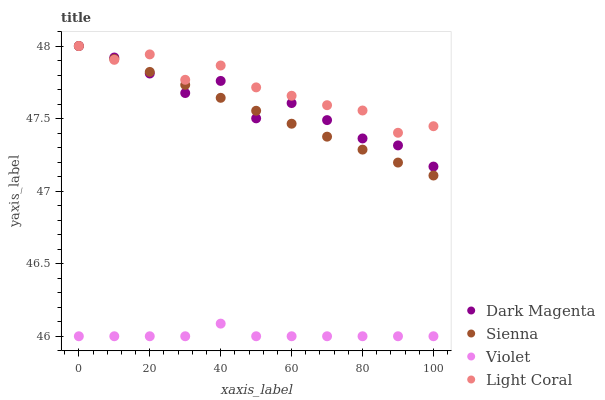Does Violet have the minimum area under the curve?
Answer yes or no. Yes. Does Light Coral have the maximum area under the curve?
Answer yes or no. Yes. Does Dark Magenta have the minimum area under the curve?
Answer yes or no. No. Does Dark Magenta have the maximum area under the curve?
Answer yes or no. No. Is Sienna the smoothest?
Answer yes or no. Yes. Is Dark Magenta the roughest?
Answer yes or no. Yes. Is Light Coral the smoothest?
Answer yes or no. No. Is Light Coral the roughest?
Answer yes or no. No. Does Violet have the lowest value?
Answer yes or no. Yes. Does Dark Magenta have the lowest value?
Answer yes or no. No. Does Dark Magenta have the highest value?
Answer yes or no. Yes. Does Violet have the highest value?
Answer yes or no. No. Is Violet less than Sienna?
Answer yes or no. Yes. Is Light Coral greater than Violet?
Answer yes or no. Yes. Does Sienna intersect Dark Magenta?
Answer yes or no. Yes. Is Sienna less than Dark Magenta?
Answer yes or no. No. Is Sienna greater than Dark Magenta?
Answer yes or no. No. Does Violet intersect Sienna?
Answer yes or no. No. 